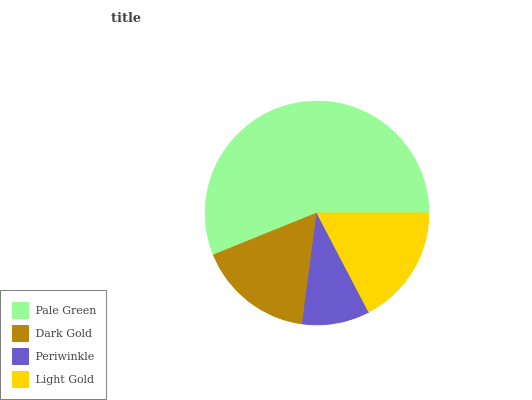Is Periwinkle the minimum?
Answer yes or no. Yes. Is Pale Green the maximum?
Answer yes or no. Yes. Is Dark Gold the minimum?
Answer yes or no. No. Is Dark Gold the maximum?
Answer yes or no. No. Is Pale Green greater than Dark Gold?
Answer yes or no. Yes. Is Dark Gold less than Pale Green?
Answer yes or no. Yes. Is Dark Gold greater than Pale Green?
Answer yes or no. No. Is Pale Green less than Dark Gold?
Answer yes or no. No. Is Light Gold the high median?
Answer yes or no. Yes. Is Dark Gold the low median?
Answer yes or no. Yes. Is Dark Gold the high median?
Answer yes or no. No. Is Pale Green the low median?
Answer yes or no. No. 